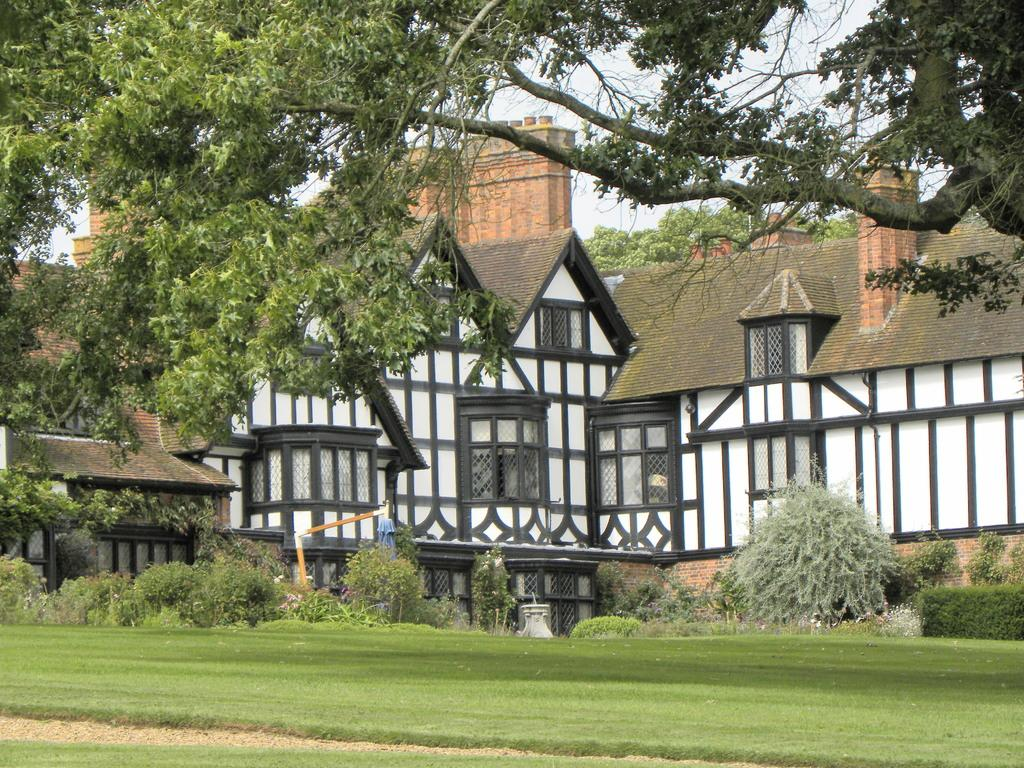What type of structures can be seen in the image? There are buildings in the image. What is located in front of the buildings? Trees and grass are visible in front of the buildings. What objects are present in front of the buildings? There are rods in front of the buildings. What can be seen in the background of the image? The sky is visible in the background of the image. What type of discussion is taking place in front of the buildings in the image? There is no discussion taking place in the image; it only shows buildings, trees, grass, rods, and the sky. Can you see a crowd of people in front of the buildings in the image? There is no crowd of people visible in the image; it only shows buildings, trees, grass, rods, and the sky. 